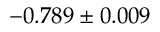<formula> <loc_0><loc_0><loc_500><loc_500>- 0 . 7 8 9 \pm 0 . 0 0 9</formula> 